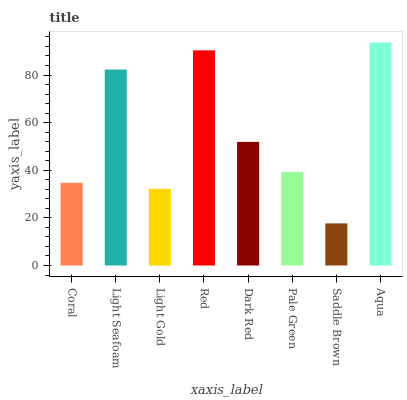Is Saddle Brown the minimum?
Answer yes or no. Yes. Is Aqua the maximum?
Answer yes or no. Yes. Is Light Seafoam the minimum?
Answer yes or no. No. Is Light Seafoam the maximum?
Answer yes or no. No. Is Light Seafoam greater than Coral?
Answer yes or no. Yes. Is Coral less than Light Seafoam?
Answer yes or no. Yes. Is Coral greater than Light Seafoam?
Answer yes or no. No. Is Light Seafoam less than Coral?
Answer yes or no. No. Is Dark Red the high median?
Answer yes or no. Yes. Is Pale Green the low median?
Answer yes or no. Yes. Is Red the high median?
Answer yes or no. No. Is Red the low median?
Answer yes or no. No. 